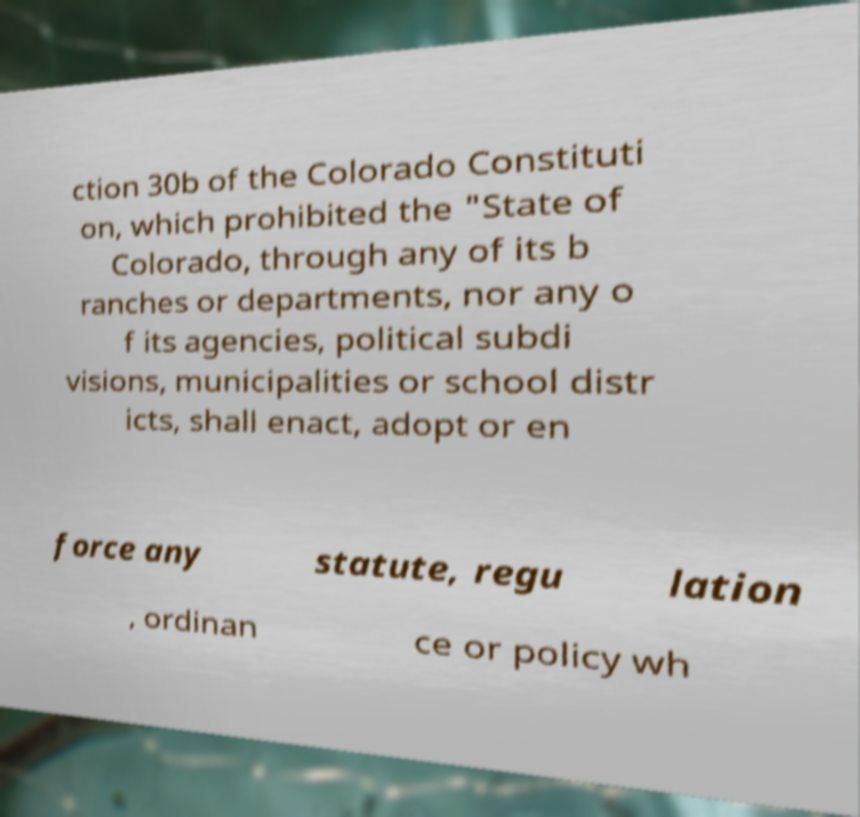What messages or text are displayed in this image? I need them in a readable, typed format. ction 30b of the Colorado Constituti on, which prohibited the "State of Colorado, through any of its b ranches or departments, nor any o f its agencies, political subdi visions, municipalities or school distr icts, shall enact, adopt or en force any statute, regu lation , ordinan ce or policy wh 